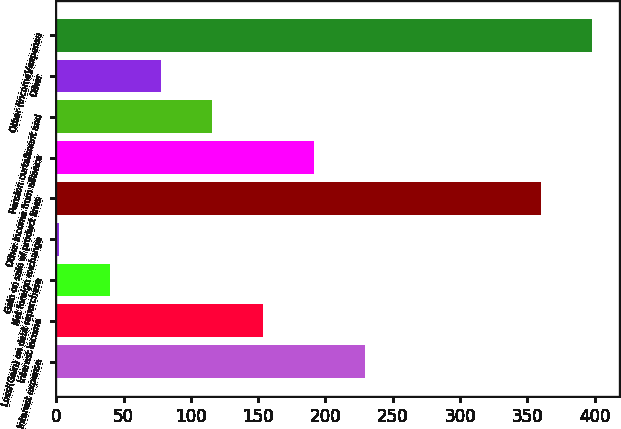Convert chart. <chart><loc_0><loc_0><loc_500><loc_500><bar_chart><fcel>Interest expense<fcel>Interest income<fcel>Loss/(Gain) on debt repurchase<fcel>Net foreign exchange<fcel>Gain on sale of product lines<fcel>Other income from alliance<fcel>Pension curtailment and<fcel>Other<fcel>Other (income)/expense<nl><fcel>229.4<fcel>153.6<fcel>39.9<fcel>2<fcel>360<fcel>191.5<fcel>115.7<fcel>77.8<fcel>397.9<nl></chart> 